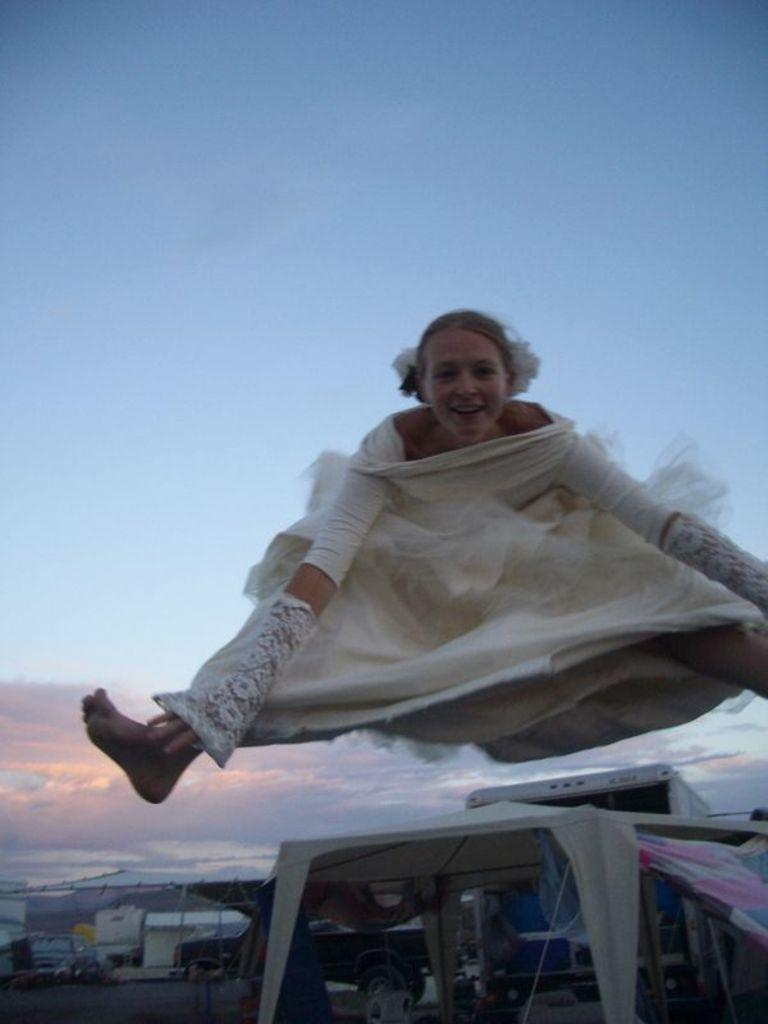Who is the main subject in the image? There is a woman in the center of the image. What is the woman doing in the image? The woman is jumping. What can be seen at the bottom of the image? There are vehicles, poles, and other objects at the bottom of the image. What is visible at the top of the image? The sky is visible at the top of the image. What are the names of the chickens in the image? There are no chickens present in the image. Can you tell me how many toes the woman has on her right foot? The image does not provide enough detail to determine the number of toes on the woman's foot. 